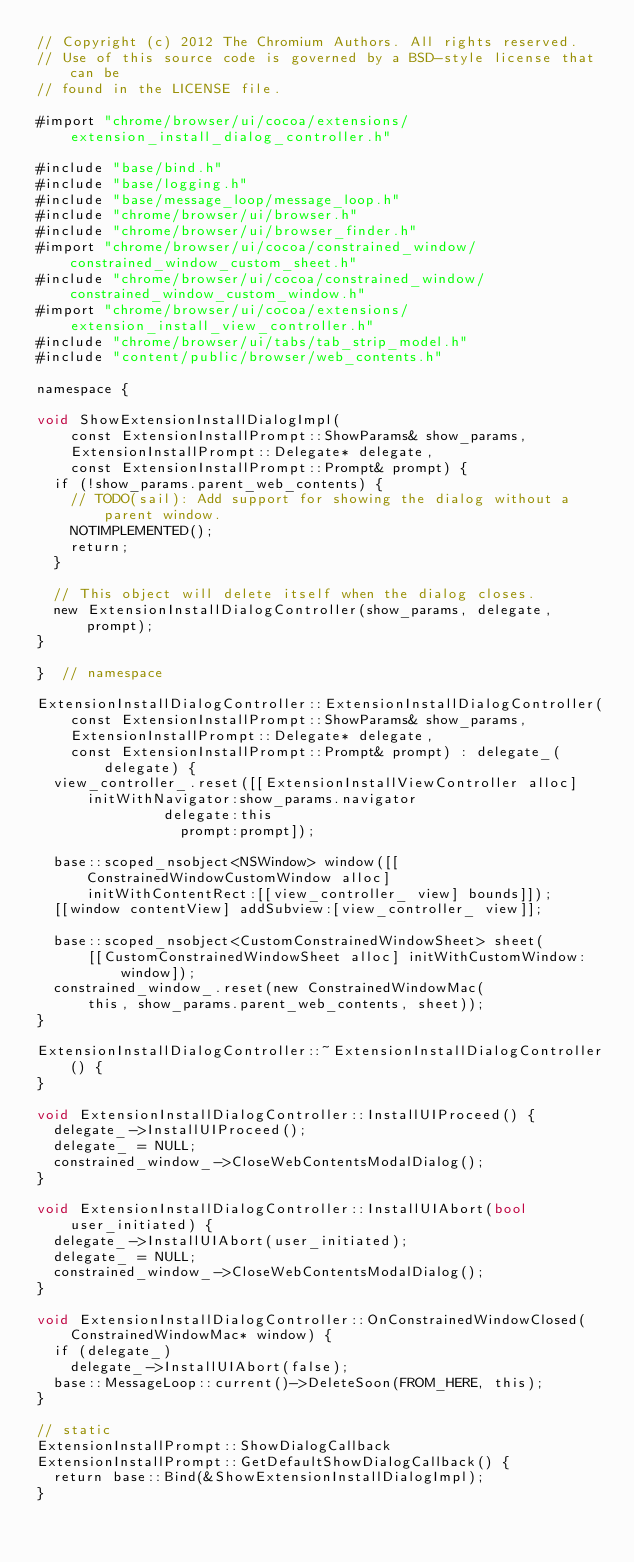Convert code to text. <code><loc_0><loc_0><loc_500><loc_500><_ObjectiveC_>// Copyright (c) 2012 The Chromium Authors. All rights reserved.
// Use of this source code is governed by a BSD-style license that can be
// found in the LICENSE file.

#import "chrome/browser/ui/cocoa/extensions/extension_install_dialog_controller.h"

#include "base/bind.h"
#include "base/logging.h"
#include "base/message_loop/message_loop.h"
#include "chrome/browser/ui/browser.h"
#include "chrome/browser/ui/browser_finder.h"
#import "chrome/browser/ui/cocoa/constrained_window/constrained_window_custom_sheet.h"
#include "chrome/browser/ui/cocoa/constrained_window/constrained_window_custom_window.h"
#import "chrome/browser/ui/cocoa/extensions/extension_install_view_controller.h"
#include "chrome/browser/ui/tabs/tab_strip_model.h"
#include "content/public/browser/web_contents.h"

namespace {

void ShowExtensionInstallDialogImpl(
    const ExtensionInstallPrompt::ShowParams& show_params,
    ExtensionInstallPrompt::Delegate* delegate,
    const ExtensionInstallPrompt::Prompt& prompt) {
  if (!show_params.parent_web_contents) {
    // TODO(sail): Add support for showing the dialog without a parent window.
    NOTIMPLEMENTED();
    return;
  }

  // This object will delete itself when the dialog closes.
  new ExtensionInstallDialogController(show_params, delegate, prompt);
}

}  // namespace

ExtensionInstallDialogController::ExtensionInstallDialogController(
    const ExtensionInstallPrompt::ShowParams& show_params,
    ExtensionInstallPrompt::Delegate* delegate,
    const ExtensionInstallPrompt::Prompt& prompt) : delegate_(delegate) {
  view_controller_.reset([[ExtensionInstallViewController alloc]
      initWithNavigator:show_params.navigator
               delegate:this
                 prompt:prompt]);

  base::scoped_nsobject<NSWindow> window([[ConstrainedWindowCustomWindow alloc]
      initWithContentRect:[[view_controller_ view] bounds]]);
  [[window contentView] addSubview:[view_controller_ view]];

  base::scoped_nsobject<CustomConstrainedWindowSheet> sheet(
      [[CustomConstrainedWindowSheet alloc] initWithCustomWindow:window]);
  constrained_window_.reset(new ConstrainedWindowMac(
      this, show_params.parent_web_contents, sheet));
}

ExtensionInstallDialogController::~ExtensionInstallDialogController() {
}

void ExtensionInstallDialogController::InstallUIProceed() {
  delegate_->InstallUIProceed();
  delegate_ = NULL;
  constrained_window_->CloseWebContentsModalDialog();
}

void ExtensionInstallDialogController::InstallUIAbort(bool user_initiated) {
  delegate_->InstallUIAbort(user_initiated);
  delegate_ = NULL;
  constrained_window_->CloseWebContentsModalDialog();
}

void ExtensionInstallDialogController::OnConstrainedWindowClosed(
    ConstrainedWindowMac* window) {
  if (delegate_)
    delegate_->InstallUIAbort(false);
  base::MessageLoop::current()->DeleteSoon(FROM_HERE, this);
}

// static
ExtensionInstallPrompt::ShowDialogCallback
ExtensionInstallPrompt::GetDefaultShowDialogCallback() {
  return base::Bind(&ShowExtensionInstallDialogImpl);
}
</code> 